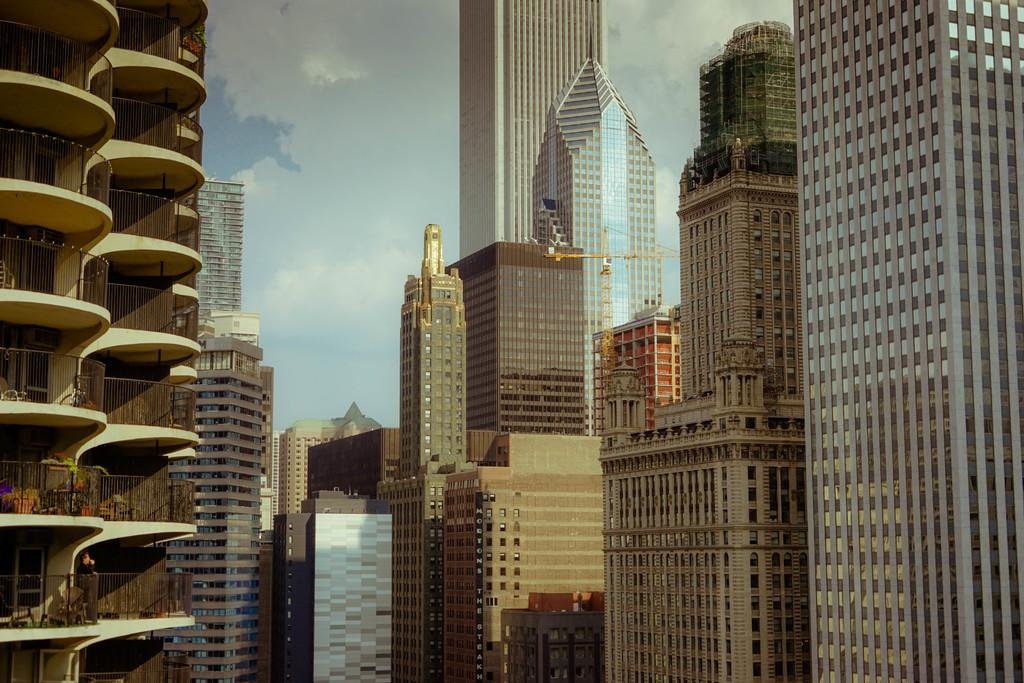What type of structures can be seen in the image? There are buildings in the image. What architectural feature is present on some of the buildings? There are iron grilles in the image. What construction equipment is visible in the image? There is a crane in the image. Can you describe the person in the image? There is a person in the image. What can be seen in the background of the image? The sky is visible in the background of the image. How does the person in the image communicate with their mom on the island? There is no island or reference to a mom in the image; it features buildings, iron grilles, a crane, and a person. What type of slip is the person wearing in the image? There is no indication of the person's clothing in the image, so it cannot be determined if they are wearing a slip or not. 